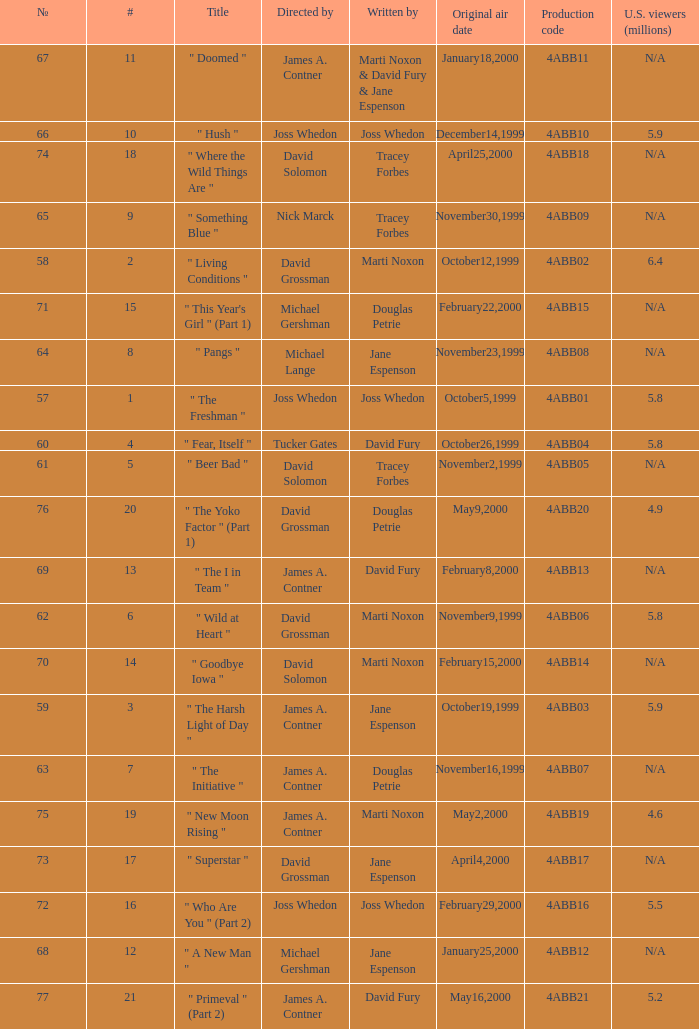What is the season 4 # for the production code of 4abb07? 7.0. 